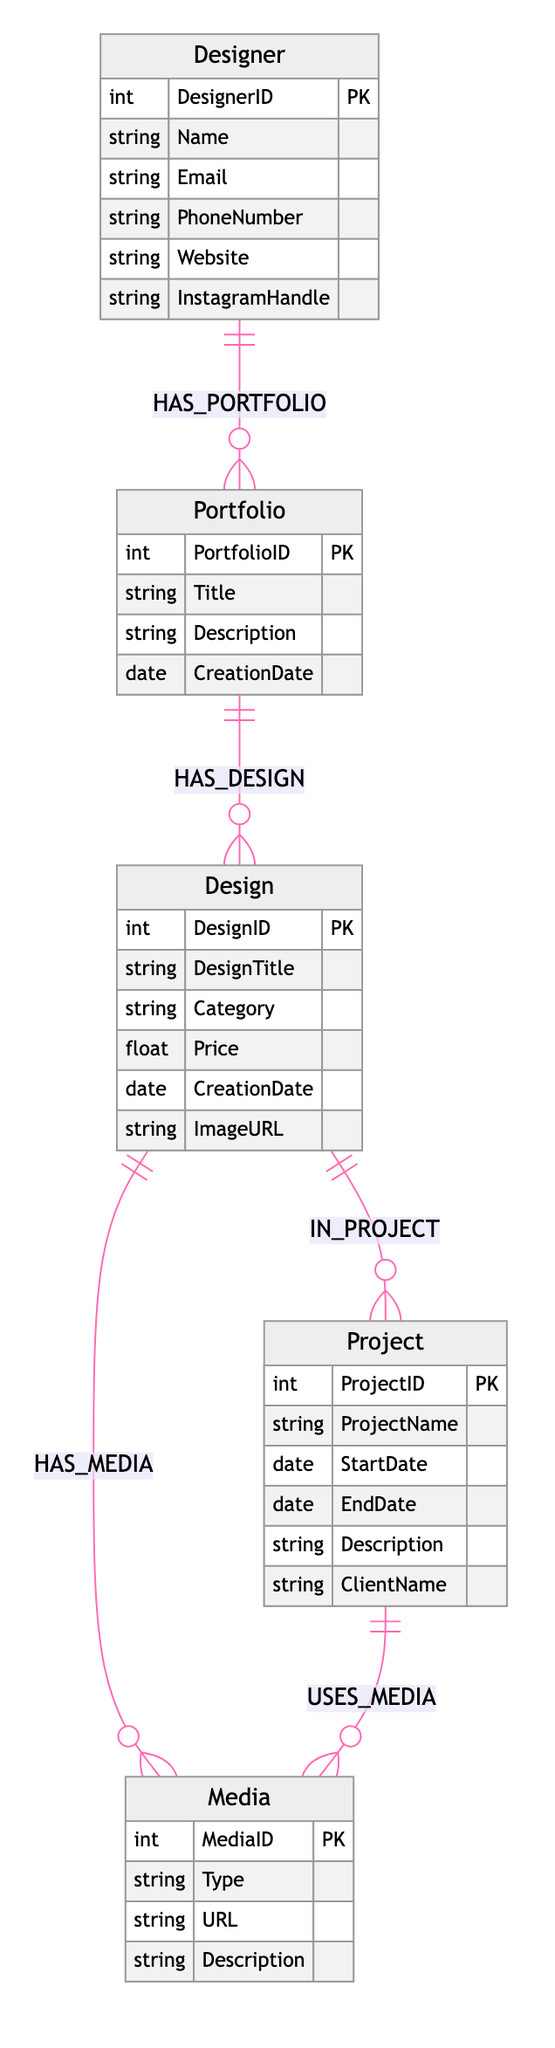What is the title of the Portfolio entity? The Portfolio entity has an attribute called Title that refers to the title of a specific portfolio created by a designer.
Answer: Title How many entities are there in the diagram? The diagram contains five entities: Designer, Portfolio, Design, Project, and Media. Counting each entity, we get a total of five.
Answer: 5 What type of relationship exists between Designer and Portfolio? The relationship between Designer and Portfolio is defined as HAS_PORTFOLIO, indicating that a designer has one or more portfolios.
Answer: HAS_PORTFOLIO What is the primary key of the Design entity? The primary key of the Design entity is DesignID, which uniquely identifies each design created within the system.
Answer: DesignID How many relationships are defined in the diagram? The diagram defines five relationships, connecting the different entities and illustrating how they interact with each other in the context of portfolio management.
Answer: 5 Which entity is connected to Design through the IN_PROJECT relationship? The Project entity is connected to Design through the IN_PROJECT relationship, which indicates that a design is part of a specific project.
Answer: Project What attribute is included in both the Portfolio and Project entities? The attribute Description is included in both the Portfolio and Project entities, providing descriptive text for each.
Answer: Description What can be inferred about the relationship between Design and Media? The relationship between Design and Media is defined as HAS_MEDIA, indicating that a design can have associated media files such as images that showcase the design work.
Answer: HAS_MEDIA 